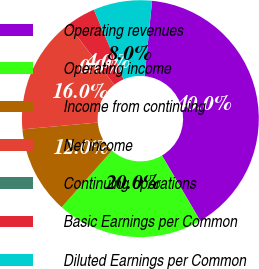Convert chart to OTSL. <chart><loc_0><loc_0><loc_500><loc_500><pie_chart><fcel>Operating revenues<fcel>Operating income<fcel>Income from continuing<fcel>Net income<fcel>Continuing operations<fcel>Basic Earnings per Common<fcel>Diluted Earnings per Common<nl><fcel>39.98%<fcel>20.0%<fcel>12.0%<fcel>16.0%<fcel>0.01%<fcel>4.01%<fcel>8.0%<nl></chart> 